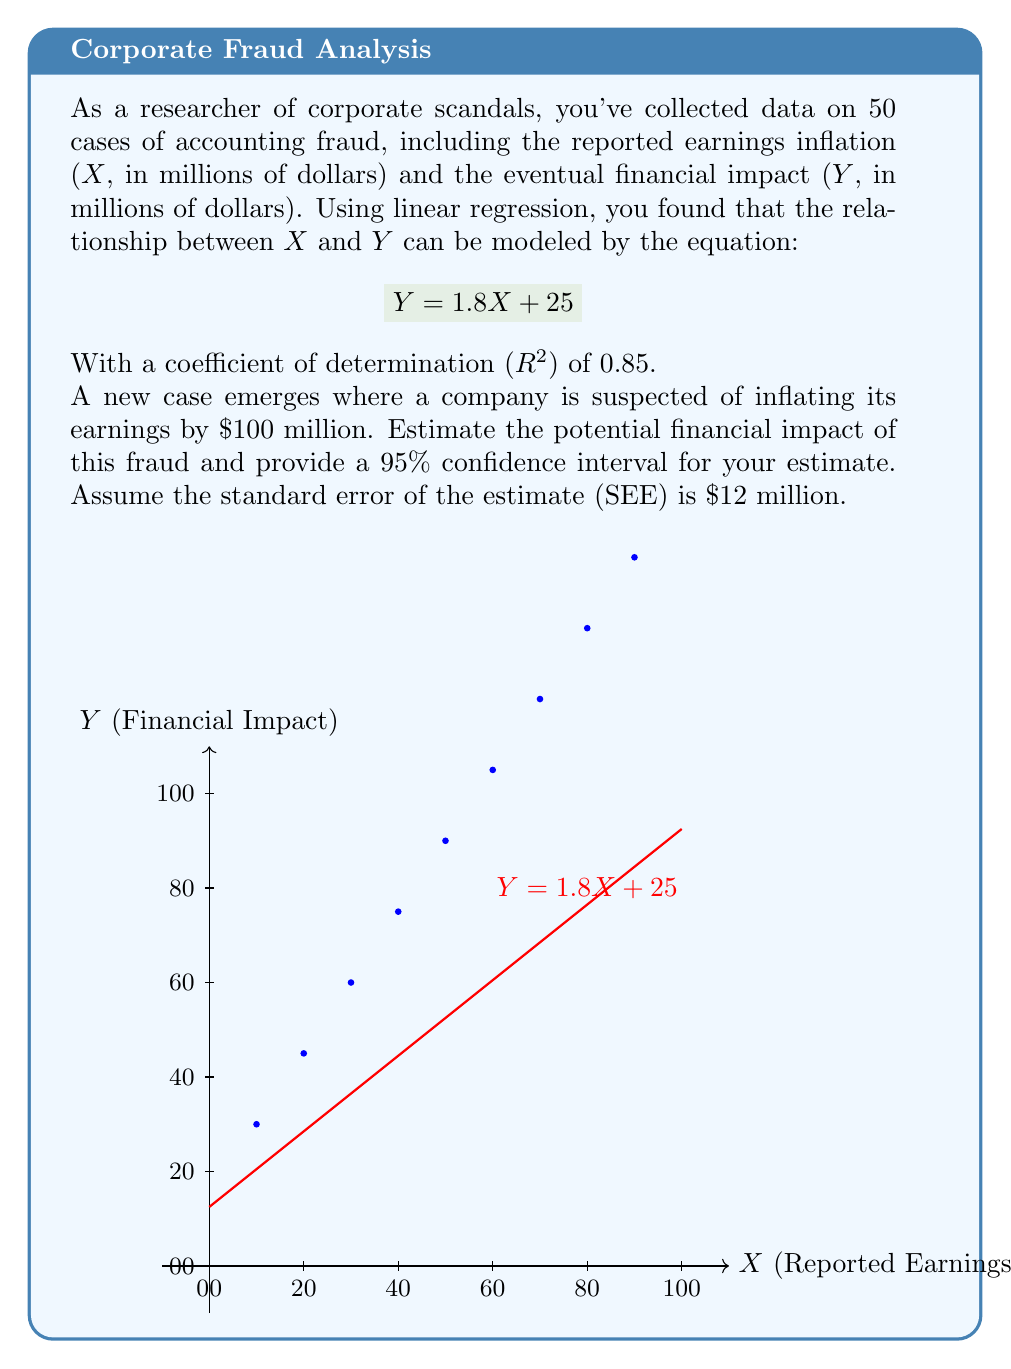Provide a solution to this math problem. Let's approach this step-by-step:

1) The regression equation is $Y = 1.8X + 25$, where X is the reported earnings inflation and Y is the financial impact.

2) For the new case, X = $100 million. We can estimate Y by plugging this into our equation:

   $Y = 1.8(100) + 25 = 180 + 25 = 205$

   So, our point estimate for the financial impact is $205 million.

3) To calculate the confidence interval, we need the standard error of the estimate (SEE), which is given as $12 million.

4) For a 95% confidence interval, we use a t-value of approximately 2 (for large sample sizes, the t-distribution approaches the normal distribution).

5) The formula for the confidence interval is:

   $\text{Point Estimate} \pm (t \times SEE)$

6) Plugging in our values:

   $205 \pm (2 \times 12)$
   $205 \pm 24$

7) Therefore, our 95% confidence interval is:

   $(205 - 24, 205 + 24) = (181, 229)$

This means we're 95% confident that the true financial impact will be between $181 million and $229 million.

8) The $R^2$ value of 0.85 indicates that 85% of the variability in the financial impact can be explained by the reported earnings inflation, suggesting a strong relationship between the two variables.
Answer: $205 million, with a 95% CI of ($181 million, $229 million) 